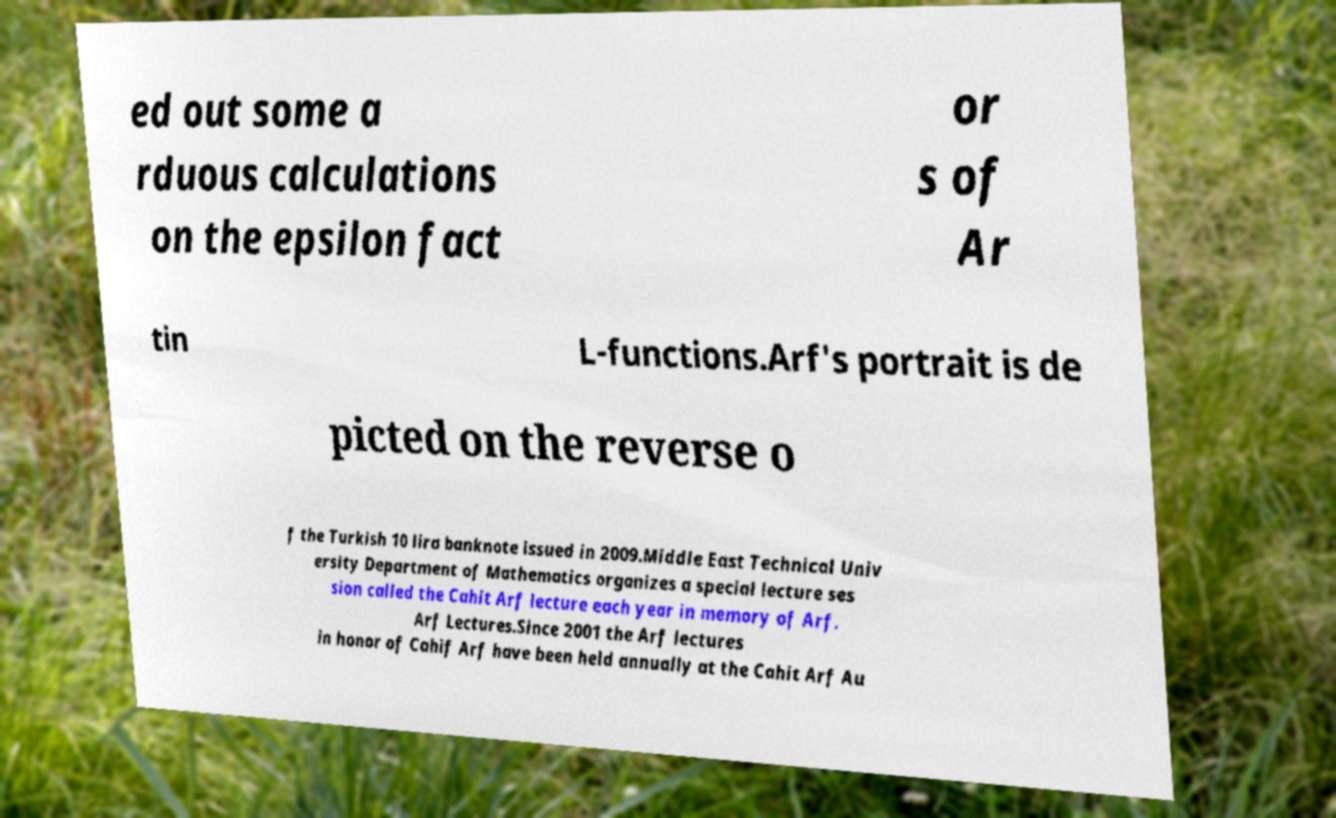For documentation purposes, I need the text within this image transcribed. Could you provide that? ed out some a rduous calculations on the epsilon fact or s of Ar tin L-functions.Arf's portrait is de picted on the reverse o f the Turkish 10 lira banknote issued in 2009.Middle East Technical Univ ersity Department of Mathematics organizes a special lecture ses sion called the Cahit Arf lecture each year in memory of Arf. Arf Lectures.Since 2001 the Arf lectures in honor of Cahif Arf have been held annually at the Cahit Arf Au 